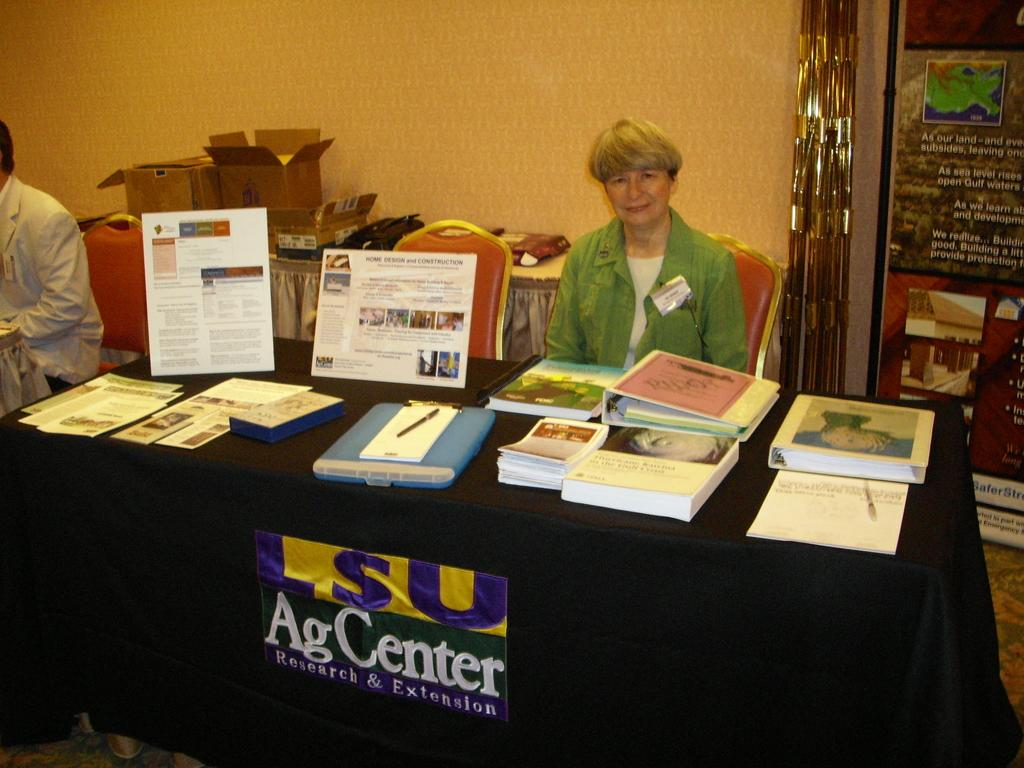Provide a one-sentence caption for the provided image. A booth for LSU AgCenter with one woman behind. 